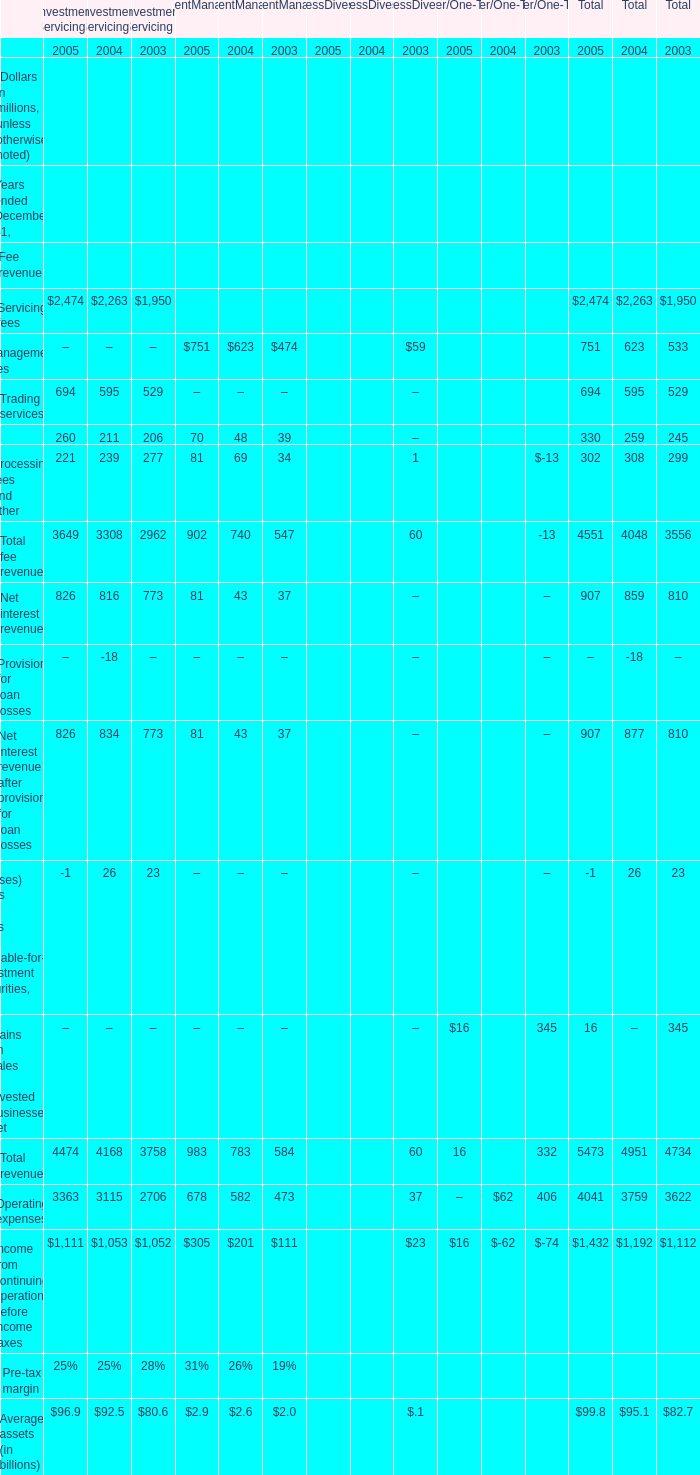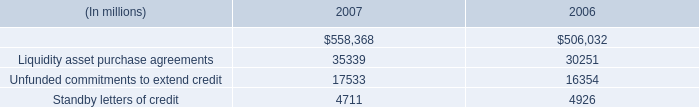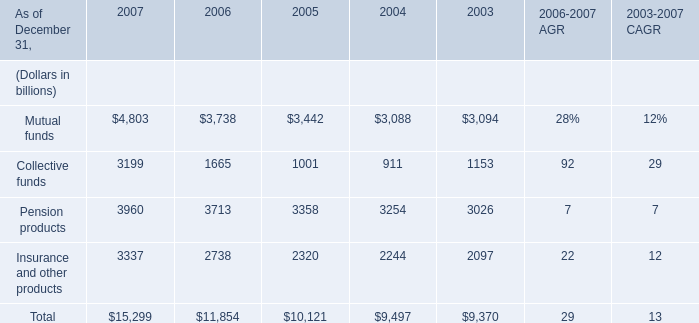What was the sum of the Management fees for Investment Management that is more than 500 million? (in million) 
Computations: (751 + 623)
Answer: 1374.0. 